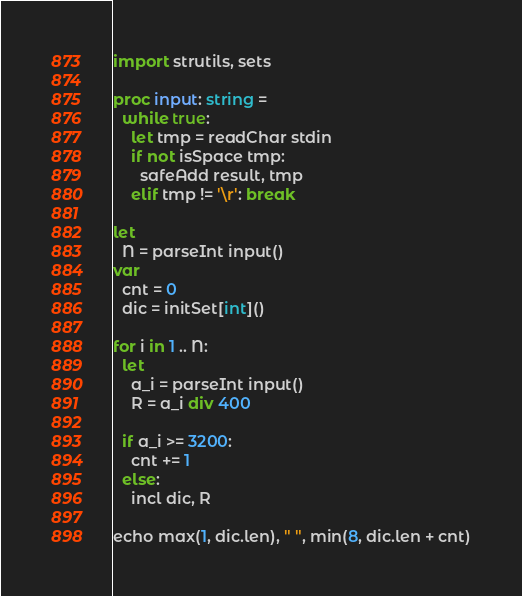<code> <loc_0><loc_0><loc_500><loc_500><_Nim_>import strutils, sets

proc input: string =
  while true:
    let tmp = readChar stdin
    if not isSpace tmp:
      safeAdd result, tmp
    elif tmp != '\r': break

let
  N = parseInt input()
var
  cnt = 0
  dic = initSet[int]()

for i in 1 .. N:
  let
    a_i = parseInt input()
    R = a_i div 400

  if a_i >= 3200:
    cnt += 1
  else:
    incl dic, R

echo max(1, dic.len), " ", min(8, dic.len + cnt)
</code> 